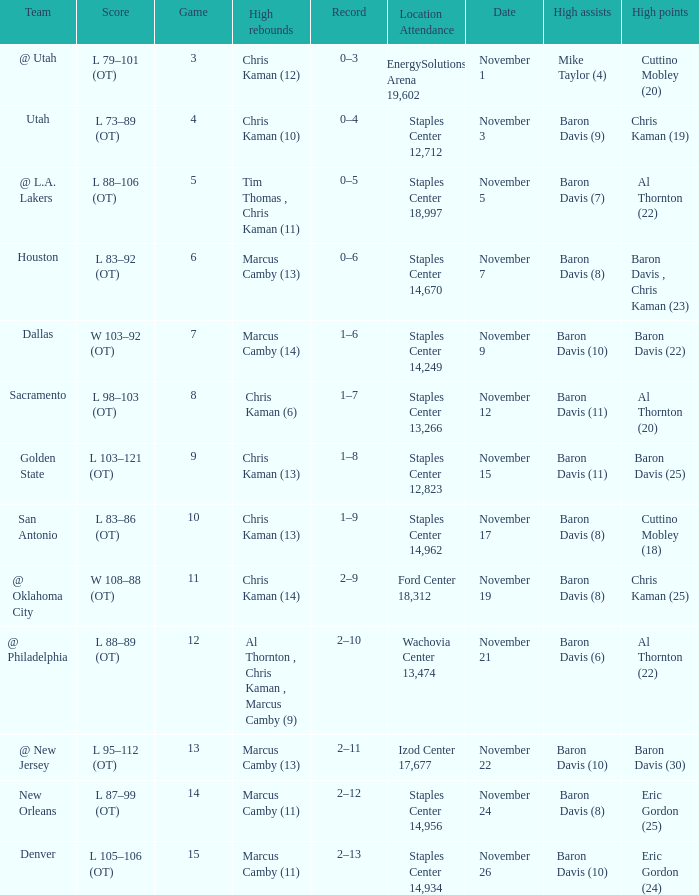Name the high points for the date of november 24 Eric Gordon (25). 